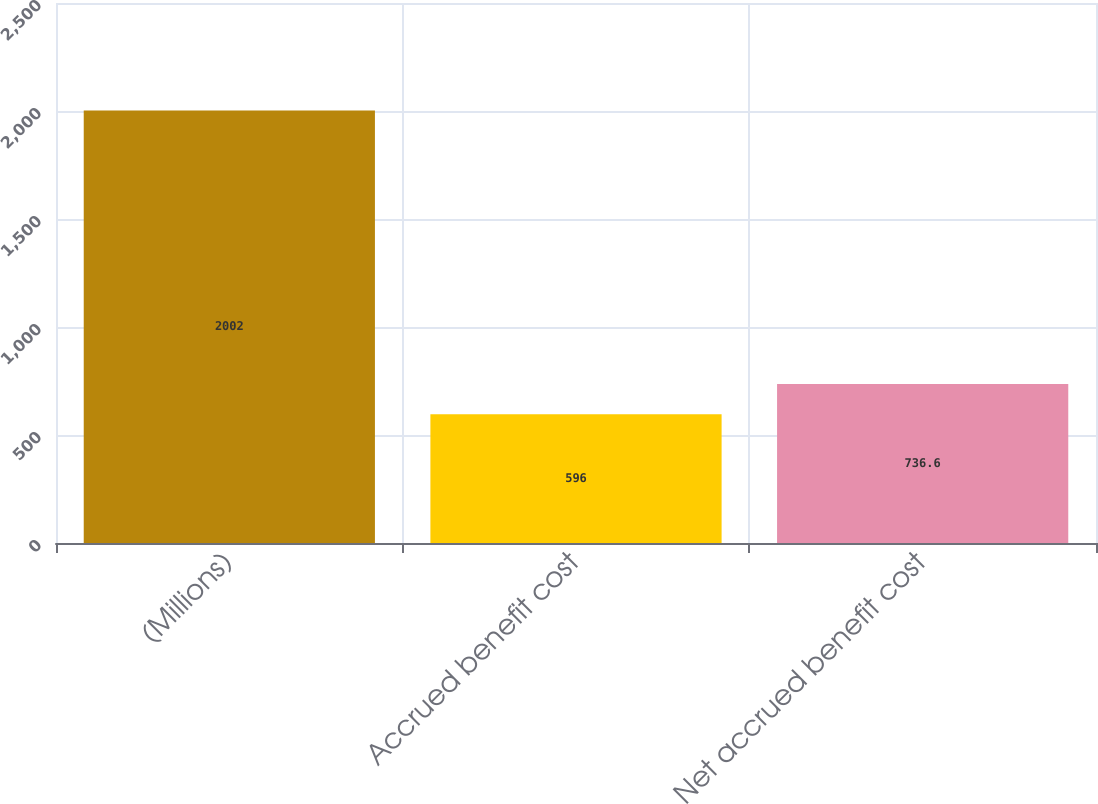<chart> <loc_0><loc_0><loc_500><loc_500><bar_chart><fcel>(Millions)<fcel>Accrued benefit cost<fcel>Net accrued benefit cost<nl><fcel>2002<fcel>596<fcel>736.6<nl></chart> 